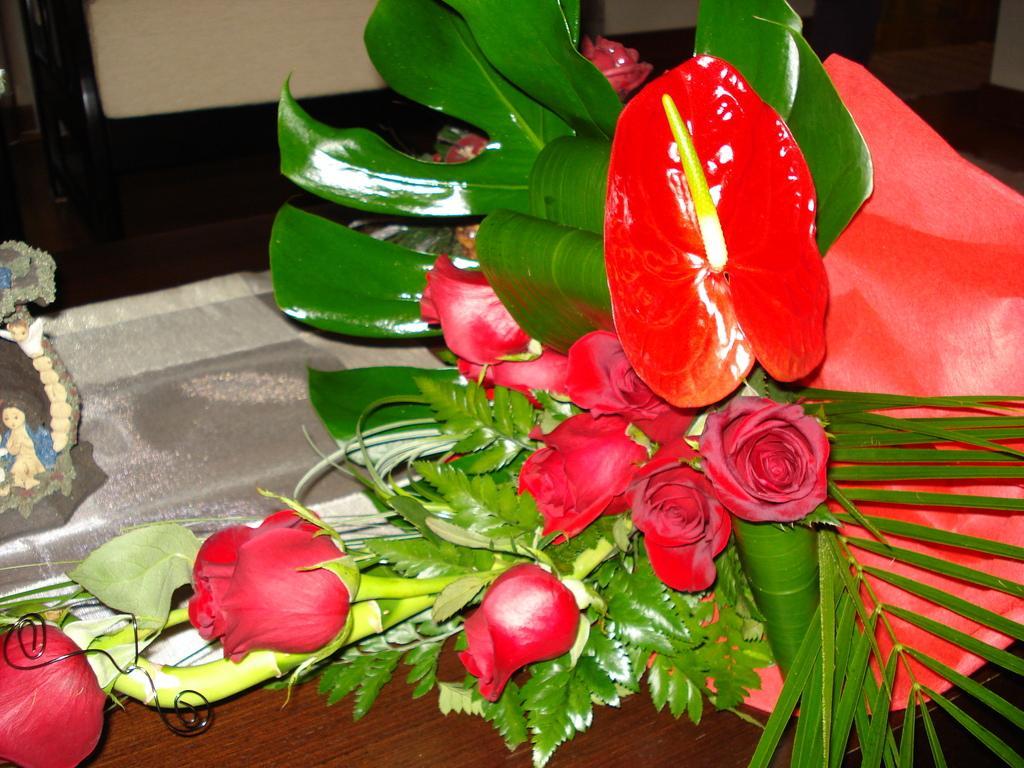Describe this image in one or two sentences. In the foreground of this picture we can see a bouquet of red roses and a show piece and some other objects are placed on the top of the wooden table. In the background we can see the chair and some other objects. 